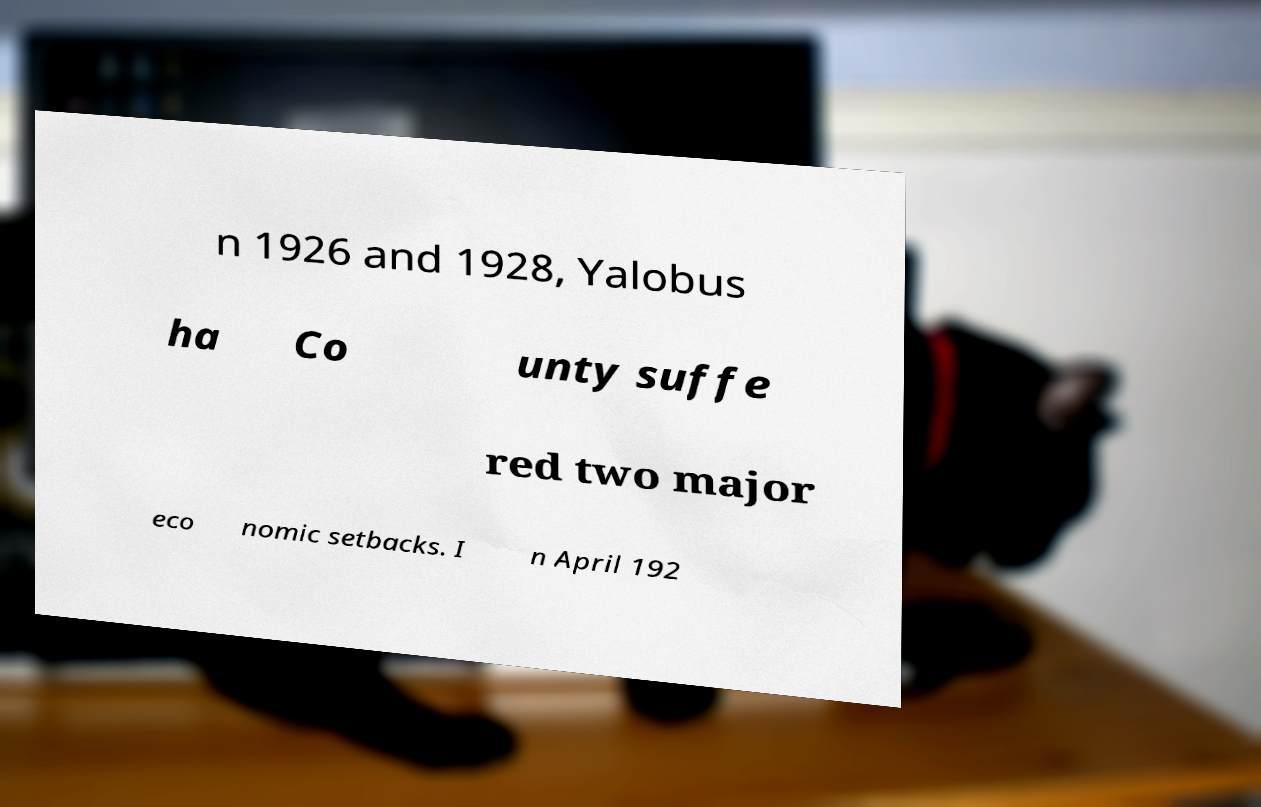What messages or text are displayed in this image? I need them in a readable, typed format. n 1926 and 1928, Yalobus ha Co unty suffe red two major eco nomic setbacks. I n April 192 